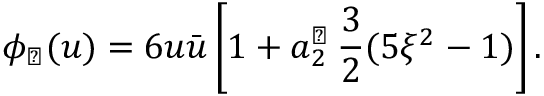<formula> <loc_0><loc_0><loc_500><loc_500>\phi _ { \perp } ( u ) = 6 u \bar { u } \left [ 1 + a _ { 2 } ^ { \perp } \, \frac { 3 } { 2 } ( 5 \xi ^ { 2 } - 1 ) \right ] .</formula> 